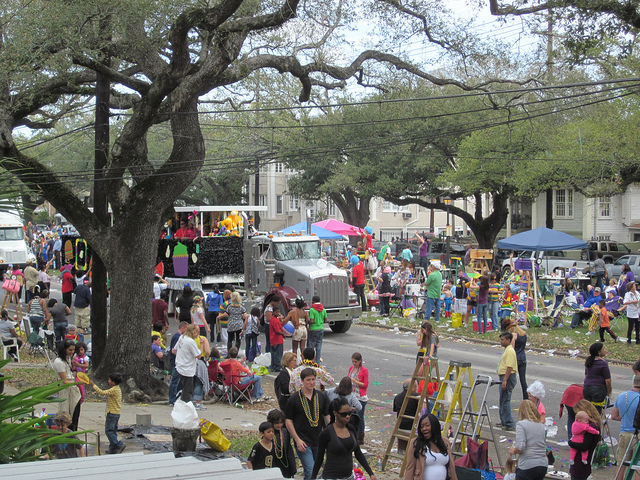<image>What is being celebrated here? It is unknown what is being celebrated here. It could be Mardi Gras, a festival, a parade, Labor Day or Cinco de Mayo. What is being celebrated here? I am not sure what is being celebrated here. It can be seen 'mardi gras', 'parade', 'festival', 'labor day', or 'cinco de mayo'. 